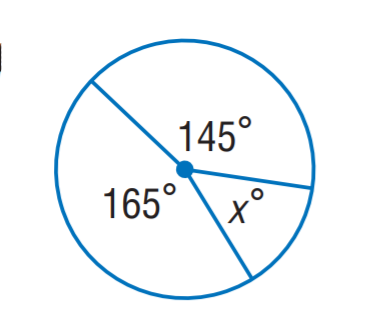Answer the mathemtical geometry problem and directly provide the correct option letter.
Question: Find x.
Choices: A: 35 B: 40 C: 50 D: 60 C 